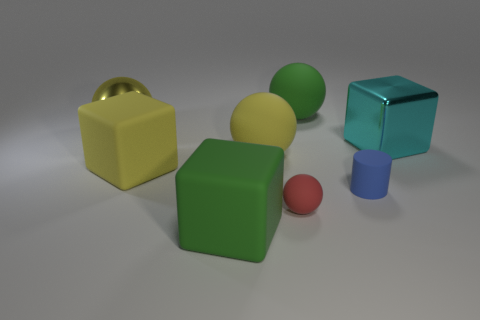There is another large ball that is the same color as the large metallic ball; what is its material?
Give a very brief answer. Rubber. Is there another small matte sphere that has the same color as the tiny ball?
Keep it short and to the point. No. What is the shape of the yellow shiny object that is the same size as the cyan shiny thing?
Offer a terse response. Sphere. Are there any things in front of the big green matte ball?
Offer a terse response. Yes. Do the big green object to the left of the small red rubber sphere and the large block that is on the right side of the green cube have the same material?
Offer a very short reply. No. What number of blue cylinders are the same size as the green rubber cube?
Your answer should be very brief. 0. There is a big yellow ball in front of the cyan cube; what material is it?
Keep it short and to the point. Rubber. How many red rubber things are the same shape as the tiny blue thing?
Give a very brief answer. 0. There is a tiny red thing that is made of the same material as the small cylinder; what is its shape?
Give a very brief answer. Sphere. The large green thing behind the rubber cube to the left of the large green matte object that is in front of the yellow shiny thing is what shape?
Your response must be concise. Sphere. 